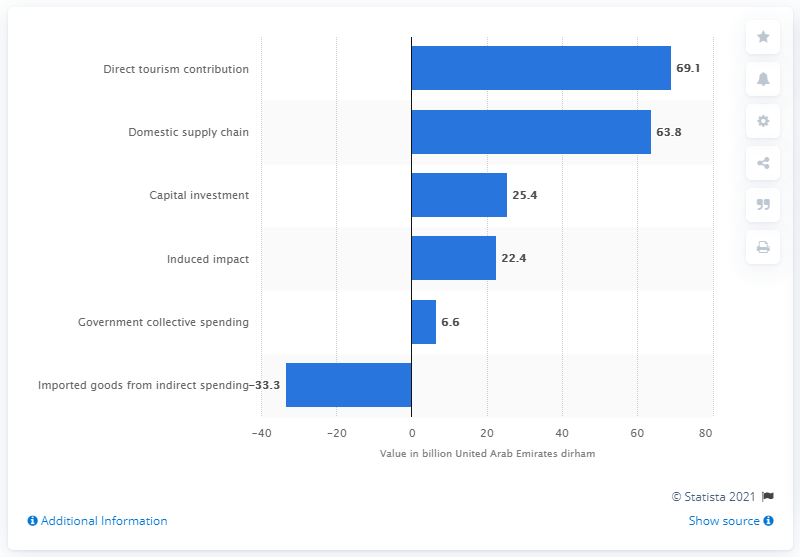Outline some significant characteristics in this image. In 2017, the direct contribution of tourism to the Gross Domestic Product (GDP) of the United Arab Emirates (UAE) was 69.1%. 